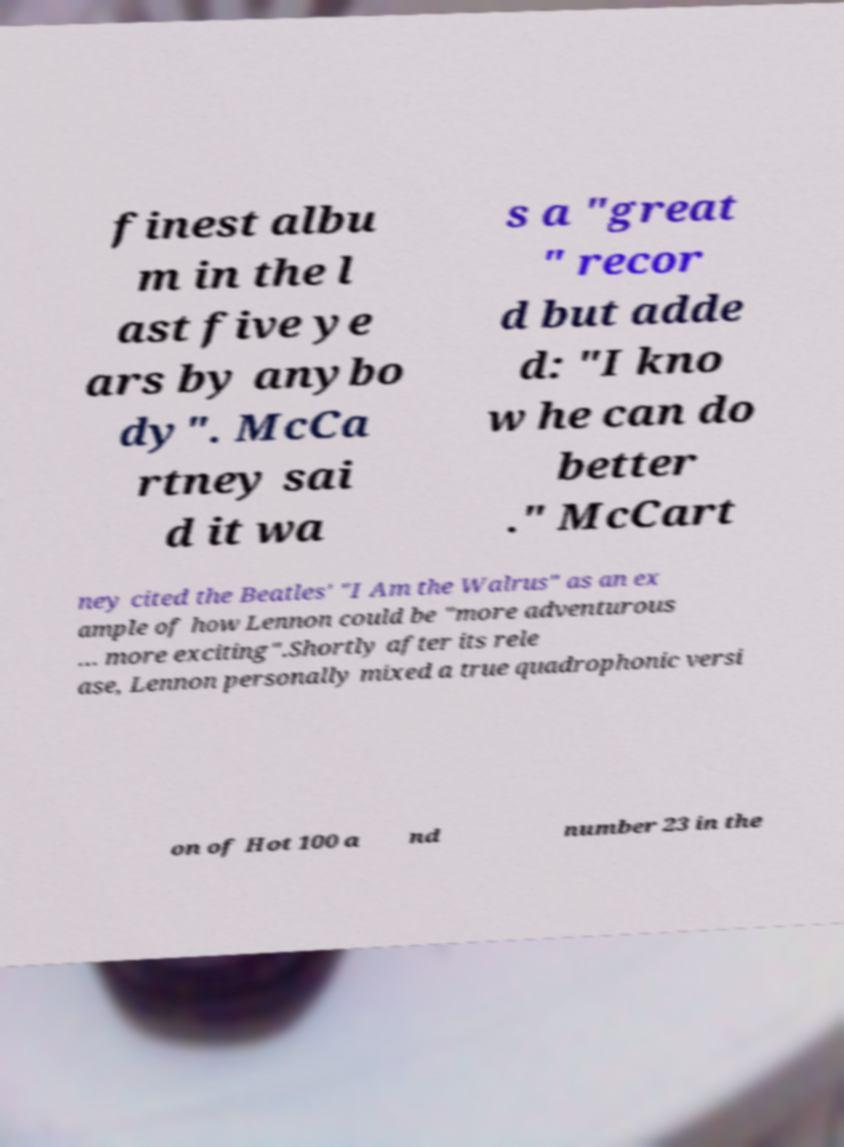I need the written content from this picture converted into text. Can you do that? finest albu m in the l ast five ye ars by anybo dy". McCa rtney sai d it wa s a "great " recor d but adde d: "I kno w he can do better ." McCart ney cited the Beatles' "I Am the Walrus" as an ex ample of how Lennon could be "more adventurous … more exciting".Shortly after its rele ase, Lennon personally mixed a true quadrophonic versi on of Hot 100 a nd number 23 in the 